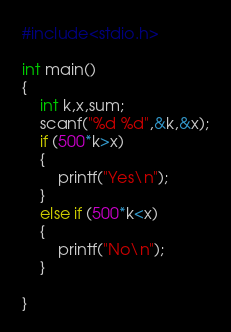Convert code to text. <code><loc_0><loc_0><loc_500><loc_500><_C_>#include<stdio.h>

int main()
{
	int k,x,sum;
	scanf("%d %d",&k,&x);
	if (500*k>x)
	{
		printf("Yes\n");
	}
	else if (500*k<x)
	{
		printf("No\n");
	}
	
}</code> 